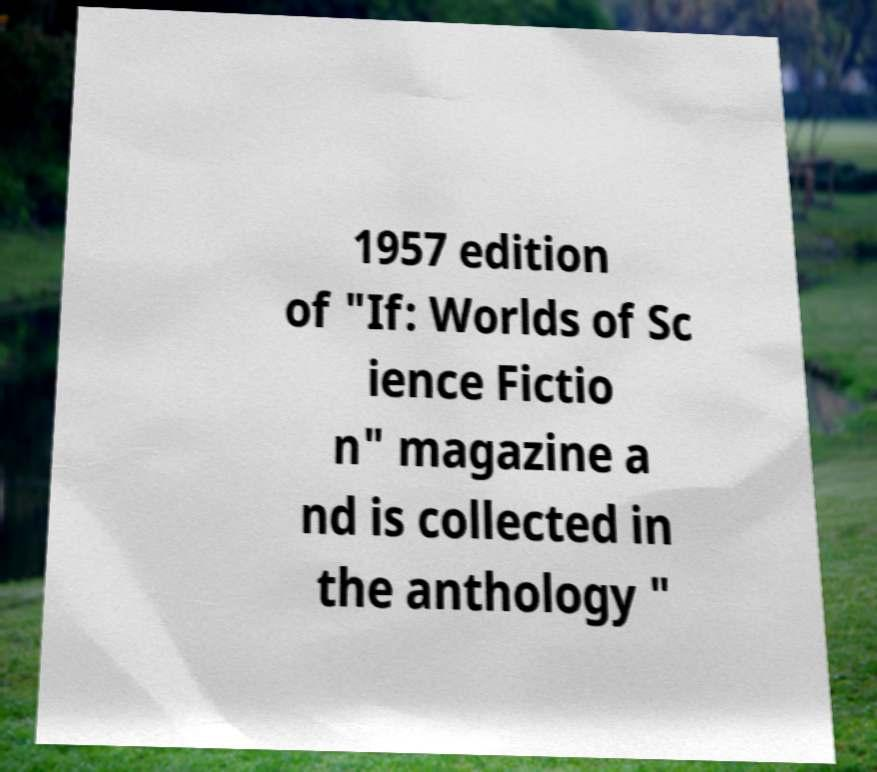What messages or text are displayed in this image? I need them in a readable, typed format. 1957 edition of "If: Worlds of Sc ience Fictio n" magazine a nd is collected in the anthology " 